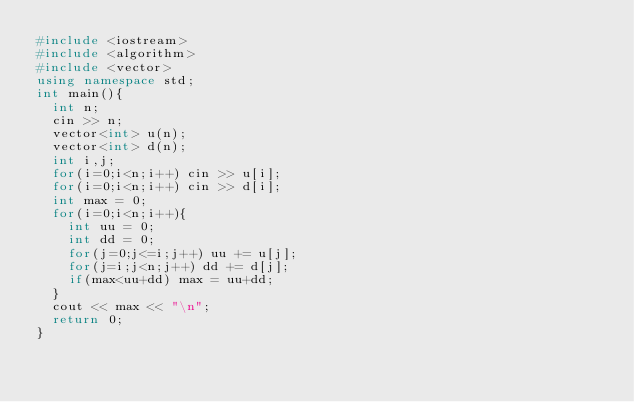Convert code to text. <code><loc_0><loc_0><loc_500><loc_500><_C++_>#include <iostream>
#include <algorithm>
#include <vector>
using namespace std;
int main(){
  int n;
  cin >> n;
  vector<int> u(n);
  vector<int> d(n);
  int i,j;
  for(i=0;i<n;i++) cin >> u[i];
  for(i=0;i<n;i++) cin >> d[i];
  int max = 0;
  for(i=0;i<n;i++){
    int uu = 0;
    int dd = 0;
    for(j=0;j<=i;j++) uu += u[j];
    for(j=i;j<n;j++) dd += d[j];
    if(max<uu+dd) max = uu+dd;
  }
  cout << max << "\n";
  return 0;
}</code> 